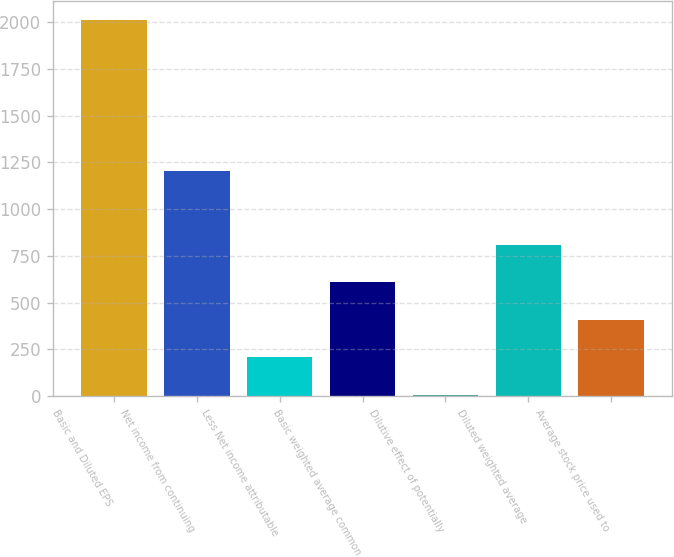Convert chart to OTSL. <chart><loc_0><loc_0><loc_500><loc_500><bar_chart><fcel>Basic and Diluted EPS<fcel>Net income from continuing<fcel>Less Net income attributable<fcel>Basic weighted average common<fcel>Dilutive effect of potentially<fcel>Diluted weighted average<fcel>Average stock price used to<nl><fcel>2012<fcel>1204<fcel>208.4<fcel>609.2<fcel>8<fcel>809.6<fcel>408.8<nl></chart> 